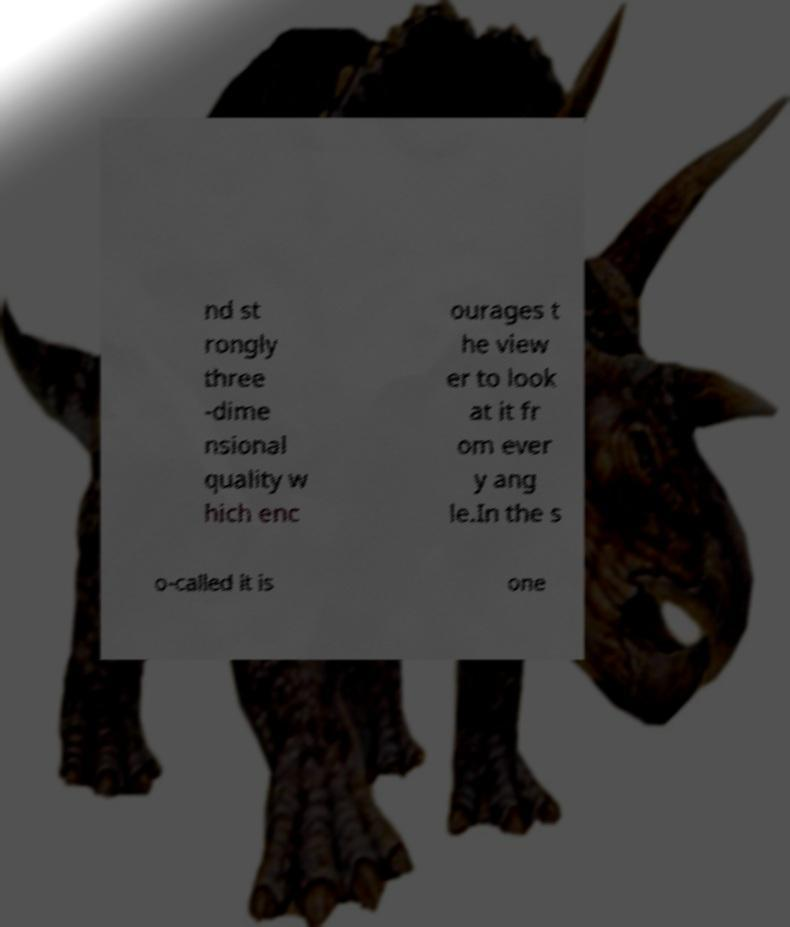What messages or text are displayed in this image? I need them in a readable, typed format. nd st rongly three -dime nsional quality w hich enc ourages t he view er to look at it fr om ever y ang le.In the s o-called it is one 